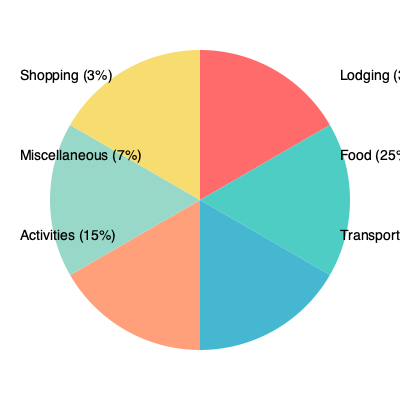You've been saving for a much-needed family vacation. The pie chart shows the breakdown of expenses for a vacation package. If the total cost of the vacation is $3,000, how much should you budget for food expenses? To calculate the budget for food expenses, we need to follow these steps:

1. Identify the percentage allocated for food from the pie chart:
   Food expenses account for 25% of the total vacation cost.

2. Convert the percentage to a decimal:
   25% = 25 ÷ 100 = 0.25

3. Calculate the food expenses by multiplying the total vacation cost by the decimal:
   Food expenses = Total cost × Percentage (in decimal)
   Food expenses = $3,000 × 0.25

4. Perform the multiplication:
   Food expenses = $750

Therefore, you should budget $750 for food expenses during your family vacation.
Answer: $750 